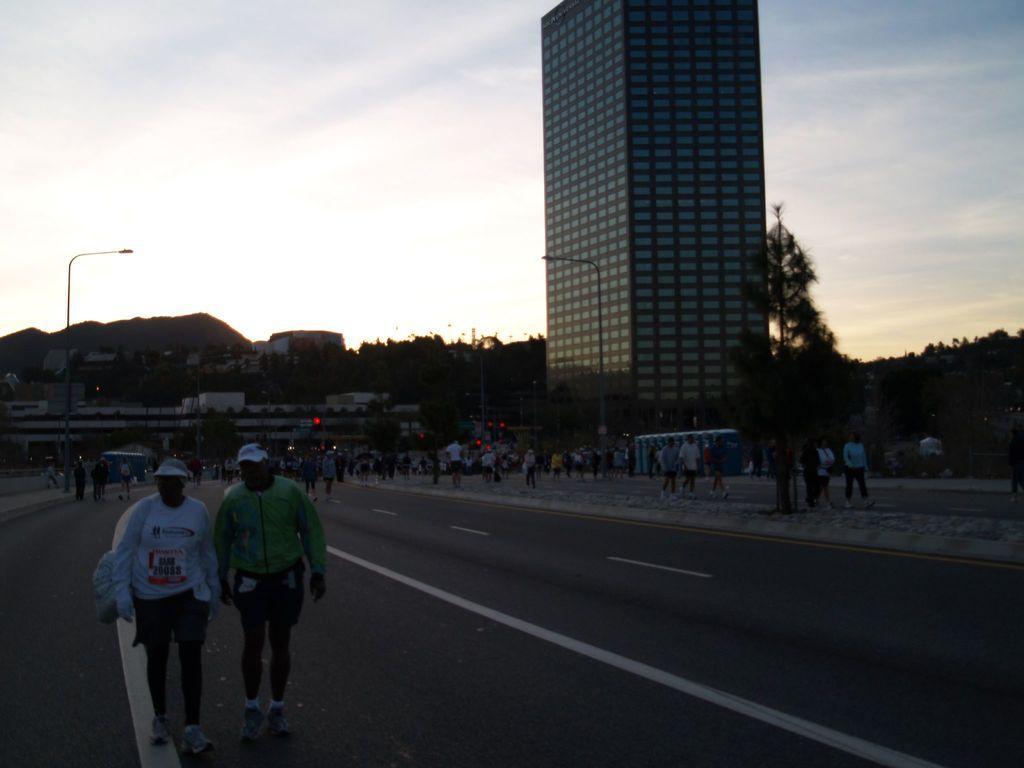Describe this image in one or two sentences. In this image we can see a group of people walking on the road, behind her there are buildings, trees, street lights and mountains. 